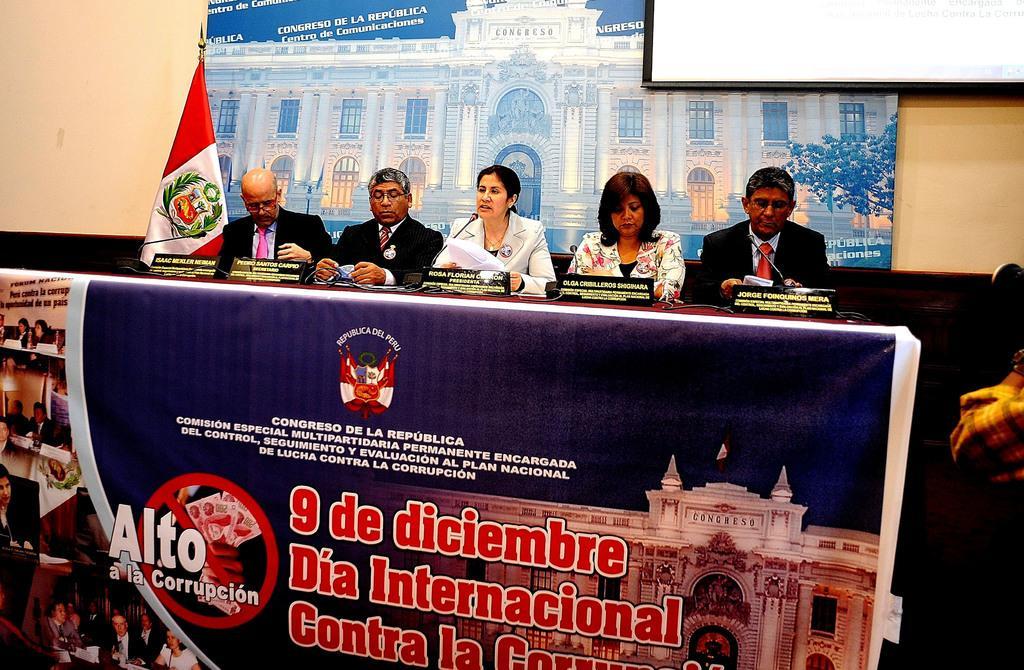Can you describe this image briefly? In this image there are some persons sitting in middle of this image. There is a flag at left side of this image and there is a wall in the background. There is a screen at top right corner of this image. There is one poster at bottom of this image. 